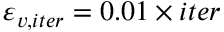<formula> <loc_0><loc_0><loc_500><loc_500>\varepsilon _ { v , i t e r } = 0 . 0 1 \times i t e r</formula> 